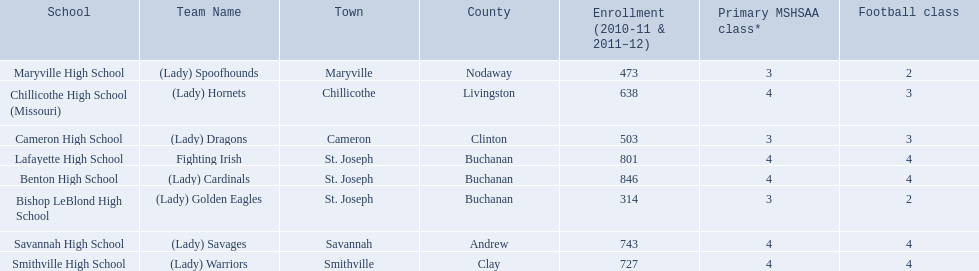What team uses green and grey as colors? Fighting Irish. What is this team called? Lafayette High School. 